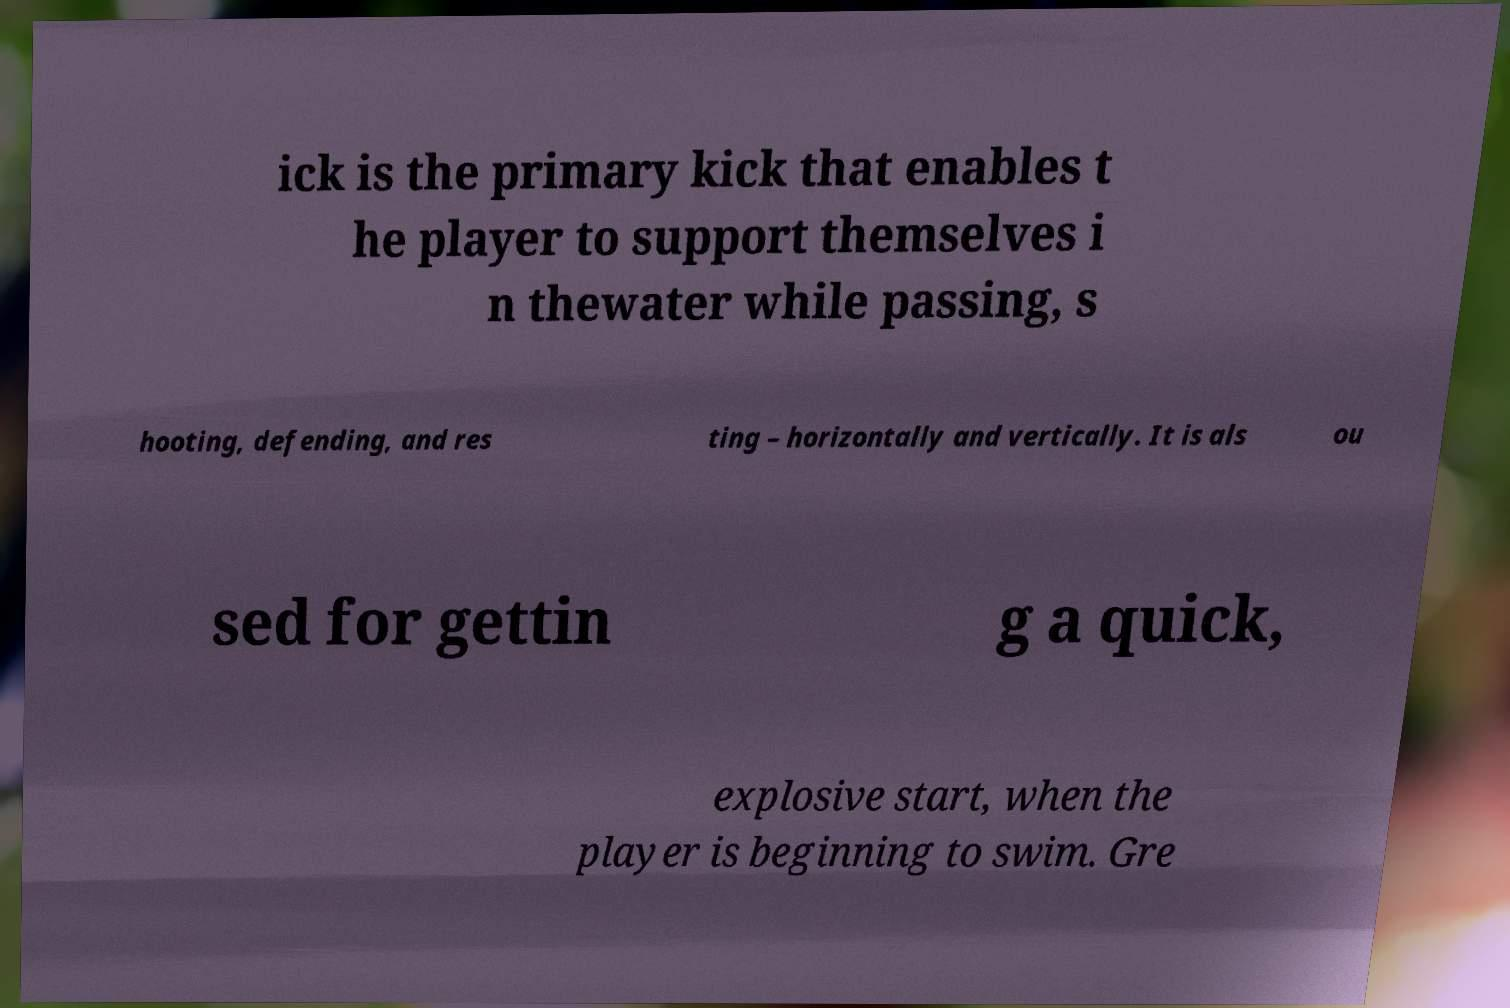What messages or text are displayed in this image? I need them in a readable, typed format. ick is the primary kick that enables t he player to support themselves i n thewater while passing, s hooting, defending, and res ting – horizontally and vertically. It is als ou sed for gettin g a quick, explosive start, when the player is beginning to swim. Gre 